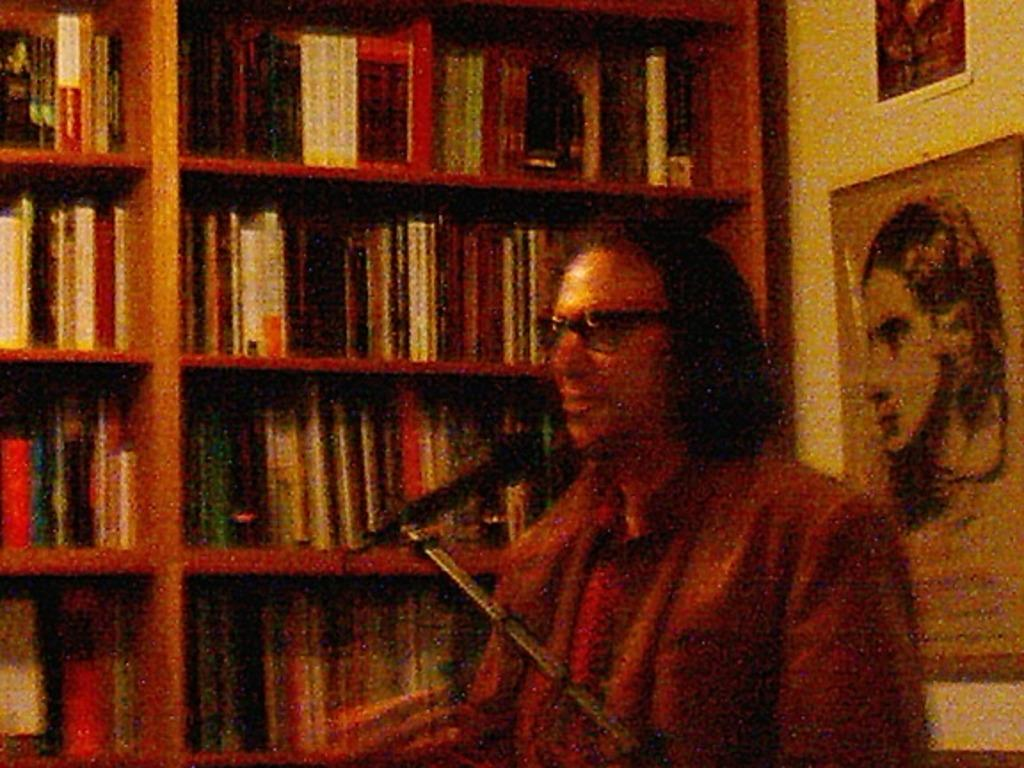<image>
Summarize the visual content of the image. A man sits in front of a bookcase with no visable titles readable. 